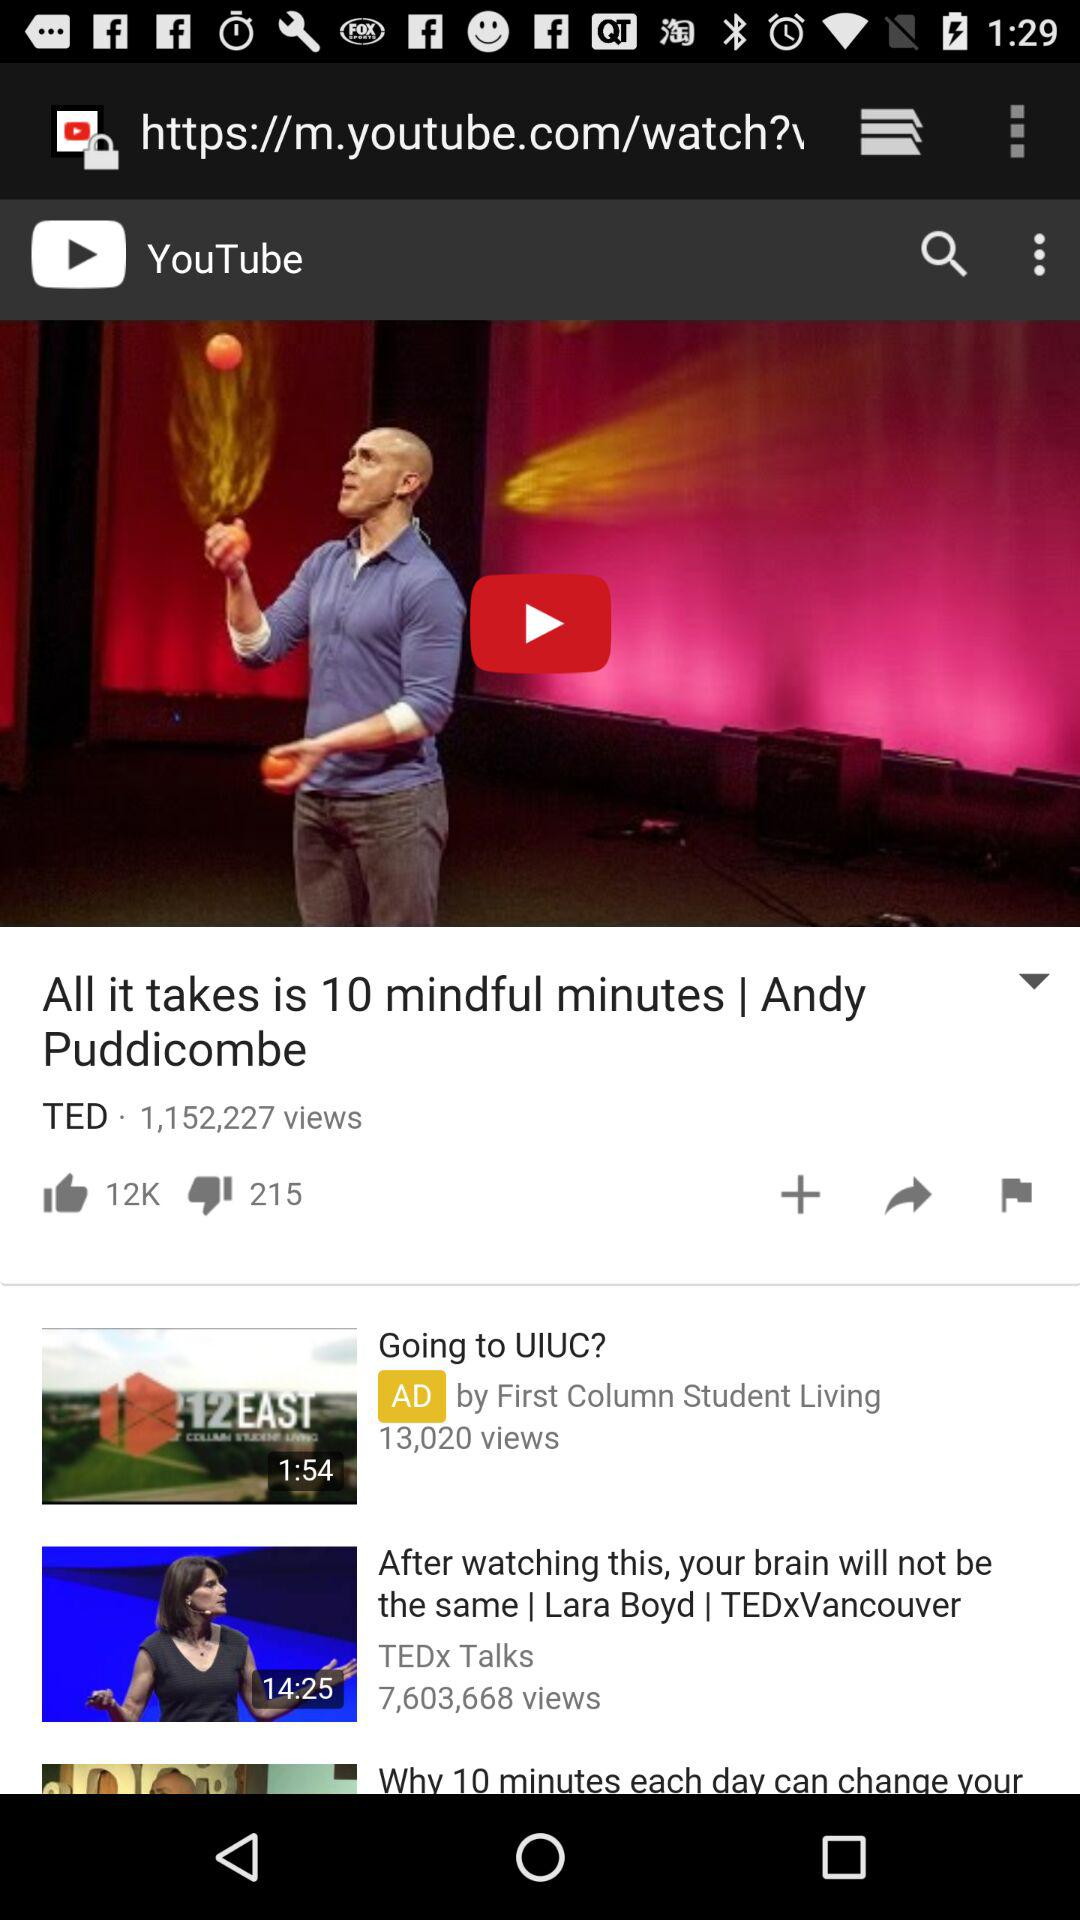How many views in total are there on the video "All it takes is 10 mindful minutes"? There are 1,152,227 views. 